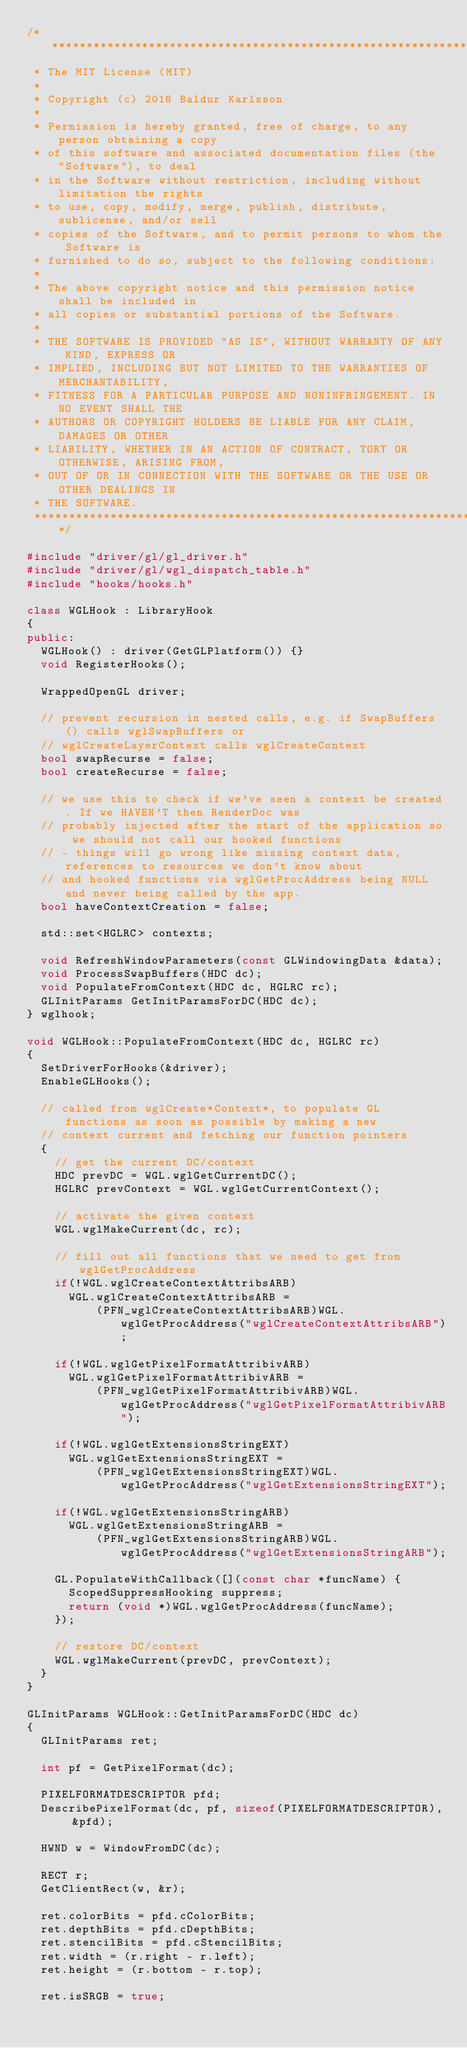Convert code to text. <code><loc_0><loc_0><loc_500><loc_500><_C++_>/******************************************************************************
 * The MIT License (MIT)
 *
 * Copyright (c) 2018 Baldur Karlsson
 *
 * Permission is hereby granted, free of charge, to any person obtaining a copy
 * of this software and associated documentation files (the "Software"), to deal
 * in the Software without restriction, including without limitation the rights
 * to use, copy, modify, merge, publish, distribute, sublicense, and/or sell
 * copies of the Software, and to permit persons to whom the Software is
 * furnished to do so, subject to the following conditions:
 *
 * The above copyright notice and this permission notice shall be included in
 * all copies or substantial portions of the Software.
 *
 * THE SOFTWARE IS PROVIDED "AS IS", WITHOUT WARRANTY OF ANY KIND, EXPRESS OR
 * IMPLIED, INCLUDING BUT NOT LIMITED TO THE WARRANTIES OF MERCHANTABILITY,
 * FITNESS FOR A PARTICULAR PURPOSE AND NONINFRINGEMENT. IN NO EVENT SHALL THE
 * AUTHORS OR COPYRIGHT HOLDERS BE LIABLE FOR ANY CLAIM, DAMAGES OR OTHER
 * LIABILITY, WHETHER IN AN ACTION OF CONTRACT, TORT OR OTHERWISE, ARISING FROM,
 * OUT OF OR IN CONNECTION WITH THE SOFTWARE OR THE USE OR OTHER DEALINGS IN
 * THE SOFTWARE.
 ******************************************************************************/

#include "driver/gl/gl_driver.h"
#include "driver/gl/wgl_dispatch_table.h"
#include "hooks/hooks.h"

class WGLHook : LibraryHook
{
public:
  WGLHook() : driver(GetGLPlatform()) {}
  void RegisterHooks();

  WrappedOpenGL driver;

  // prevent recursion in nested calls, e.g. if SwapBuffers() calls wglSwapBuffers or
  // wglCreateLayerContext calls wglCreateContext
  bool swapRecurse = false;
  bool createRecurse = false;

  // we use this to check if we've seen a context be created. If we HAVEN'T then RenderDoc was
  // probably injected after the start of the application so we should not call our hooked functions
  // - things will go wrong like missing context data, references to resources we don't know about
  // and hooked functions via wglGetProcAddress being NULL and never being called by the app.
  bool haveContextCreation = false;

  std::set<HGLRC> contexts;

  void RefreshWindowParameters(const GLWindowingData &data);
  void ProcessSwapBuffers(HDC dc);
  void PopulateFromContext(HDC dc, HGLRC rc);
  GLInitParams GetInitParamsForDC(HDC dc);
} wglhook;

void WGLHook::PopulateFromContext(HDC dc, HGLRC rc)
{
  SetDriverForHooks(&driver);
  EnableGLHooks();

  // called from wglCreate*Context*, to populate GL functions as soon as possible by making a new
  // context current and fetching our function pointers
  {
    // get the current DC/context
    HDC prevDC = WGL.wglGetCurrentDC();
    HGLRC prevContext = WGL.wglGetCurrentContext();

    // activate the given context
    WGL.wglMakeCurrent(dc, rc);

    // fill out all functions that we need to get from wglGetProcAddress
    if(!WGL.wglCreateContextAttribsARB)
      WGL.wglCreateContextAttribsARB =
          (PFN_wglCreateContextAttribsARB)WGL.wglGetProcAddress("wglCreateContextAttribsARB");

    if(!WGL.wglGetPixelFormatAttribivARB)
      WGL.wglGetPixelFormatAttribivARB =
          (PFN_wglGetPixelFormatAttribivARB)WGL.wglGetProcAddress("wglGetPixelFormatAttribivARB");

    if(!WGL.wglGetExtensionsStringEXT)
      WGL.wglGetExtensionsStringEXT =
          (PFN_wglGetExtensionsStringEXT)WGL.wglGetProcAddress("wglGetExtensionsStringEXT");

    if(!WGL.wglGetExtensionsStringARB)
      WGL.wglGetExtensionsStringARB =
          (PFN_wglGetExtensionsStringARB)WGL.wglGetProcAddress("wglGetExtensionsStringARB");

    GL.PopulateWithCallback([](const char *funcName) {
      ScopedSuppressHooking suppress;
      return (void *)WGL.wglGetProcAddress(funcName);
    });

    // restore DC/context
    WGL.wglMakeCurrent(prevDC, prevContext);
  }
}

GLInitParams WGLHook::GetInitParamsForDC(HDC dc)
{
  GLInitParams ret;

  int pf = GetPixelFormat(dc);

  PIXELFORMATDESCRIPTOR pfd;
  DescribePixelFormat(dc, pf, sizeof(PIXELFORMATDESCRIPTOR), &pfd);

  HWND w = WindowFromDC(dc);

  RECT r;
  GetClientRect(w, &r);

  ret.colorBits = pfd.cColorBits;
  ret.depthBits = pfd.cDepthBits;
  ret.stencilBits = pfd.cStencilBits;
  ret.width = (r.right - r.left);
  ret.height = (r.bottom - r.top);

  ret.isSRGB = true;
</code> 